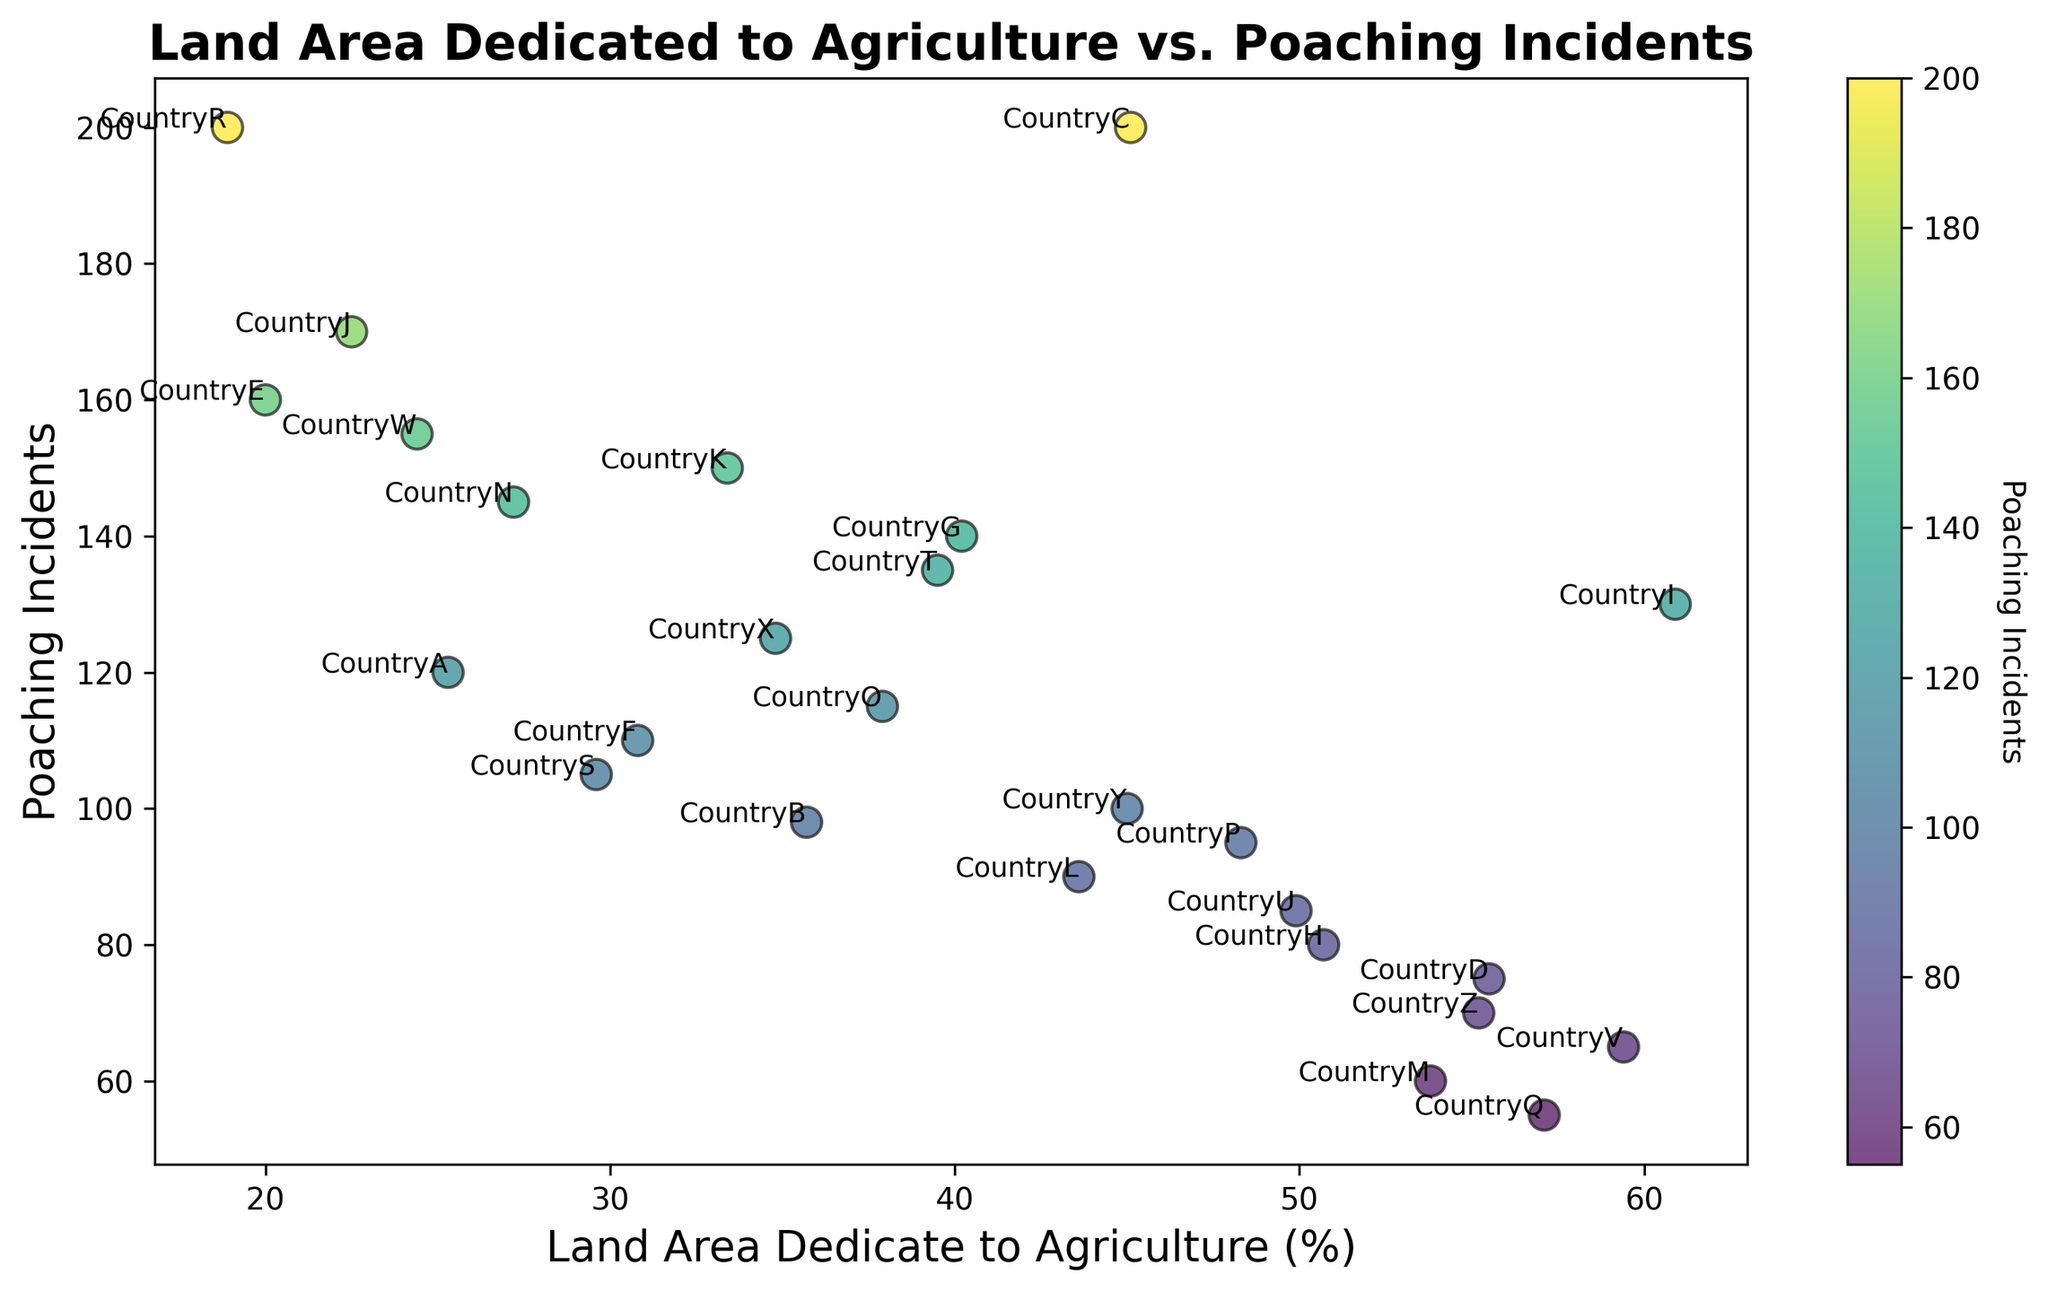Which country has the highest number of poaching incidents? To find the country with the highest number of poaching incidents, look for the data point with the highest y-axis value. Here, Country C and Country R both have the highest poaching incidents at 200.
Answer: Country C and Country R Which country has the least amount of land dedicated to agriculture? Examine the x-axis for the data point with the lowest value, which corresponds to the country with the least land area dedicated to agriculture. Country R has the lowest land area percentage at 18.9%.
Answer: Country R Which country has more poaching incidents, Country A or Country B? Analyze the y-axis values for Country A and Country B. Country A has 120 incidents, while Country B has 98. Thus, Country A has more poaching incidents.
Answer: Country A What is the difference in the number of poaching incidents between Country Q and Country M? Country Q has 55 poaching incidents and Country M has 60. The difference is calculated by subtracting the smaller value from the larger value. Thus, 60 - 55 = 5.
Answer: 5 Identify the median value of land area dedicated to agriculture among the countries. To find the median, order all the land area percentages and find the middle value. The ordered values are [18.9, 20.0, 22.5, 24.4, 25.3, 27.2, 29.6, 30.8, 33.4, 34.8, 35.7, 37.9, 39.5, 40.2, 43.6, 45.0, 45.1, 48.3, 49.9, 50.7, 53.8, 55.2, 55.5, 57.1, 59.4, 60.9]. The median value, being the 13th and 14th value's average in this 26-value list, is (37.9 + 39.5) / 2 = 38.7%.
Answer: 38.7% Which country lies closest to the midpoint of the range of poaching incidents? To find the midpoint of the range, calculate the average of the highest and lowest values: (200 + 55) / 2 = 127.5. The country closest to 127.5 is Country I with 130 incidents.
Answer: Country I How many countries have more than 100 poaching incidents? Count the number of countries with y-axis values greater than 100. The countries are A, C, E, G, I, J, K, N, O, T, and W. This sums up to 11 countries.
Answer: 11 Which country has a higher agriculture percentage, Country P or Country U? Compare the x-axis values for both countries. Country P has 48.3%, while Country U has 49.9%. Therefore, Country U has a higher agriculture percentage.
Answer: Country U Identify the country with a comparatively average poaching incident count and agriculture percentage. To find a country with approximately average values, consider those nearest the center of both axes. Country X, with 34.8% agriculture and 125 poaching incidents, is near the center.
Answer: Country X 